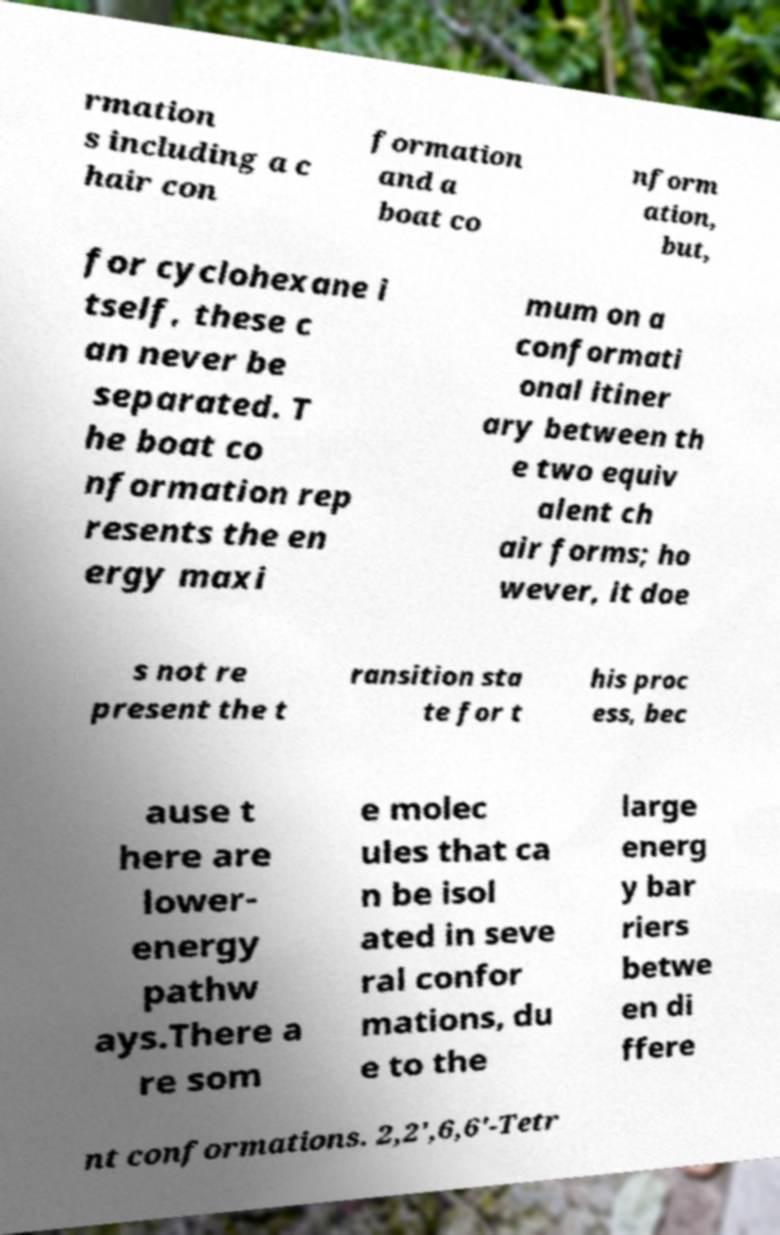Please identify and transcribe the text found in this image. rmation s including a c hair con formation and a boat co nform ation, but, for cyclohexane i tself, these c an never be separated. T he boat co nformation rep resents the en ergy maxi mum on a conformati onal itiner ary between th e two equiv alent ch air forms; ho wever, it doe s not re present the t ransition sta te for t his proc ess, bec ause t here are lower- energy pathw ays.There a re som e molec ules that ca n be isol ated in seve ral confor mations, du e to the large energ y bar riers betwe en di ffere nt conformations. 2,2',6,6'-Tetr 